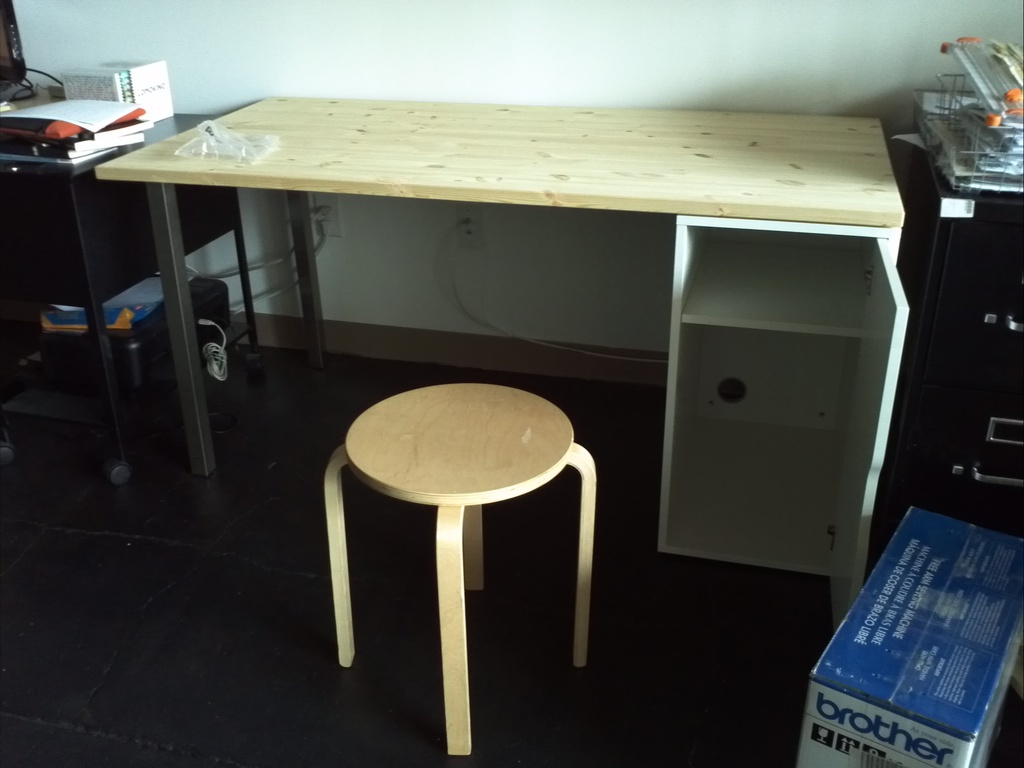Provide a one-sentence caption for the provided image. A minimalist wooden desk and a matching stool positioned on a black floor, against a backdrop of sleek, industrial features, with a box labeled 'Brother' suggesting recent or pending office equipment setup. 